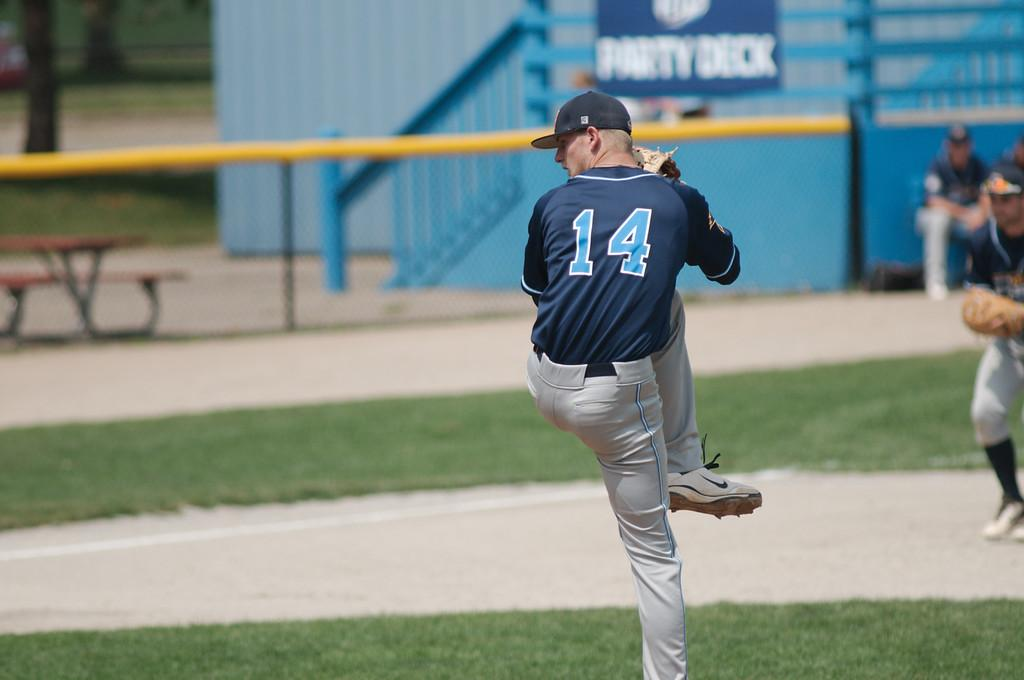Who is the main subject in the image? There is a man in the image. What can be observed about the background of the image? The background of the image is blurred. What type of natural environment is visible in the image? There is grass visible in the image. What type of seating is present in the image? There is a bench in the image. Can you describe the presence of other people in the image? There are people in the background of the image. What type of wilderness can be seen in the image? There is no wilderness present in the image; it features a man, a bench, and people in a grassy environment. 